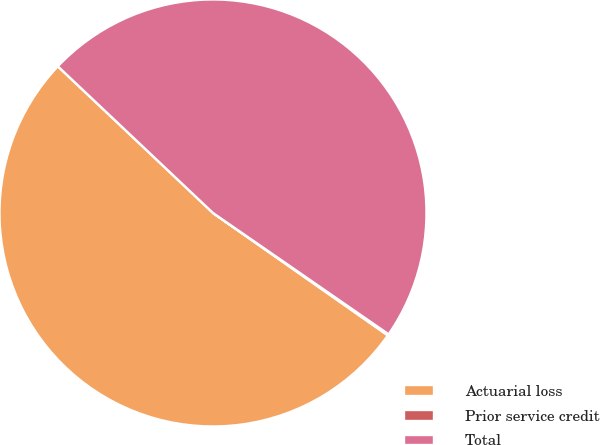Convert chart to OTSL. <chart><loc_0><loc_0><loc_500><loc_500><pie_chart><fcel>Actuarial loss<fcel>Prior service credit<fcel>Total<nl><fcel>52.33%<fcel>0.1%<fcel>47.57%<nl></chart> 